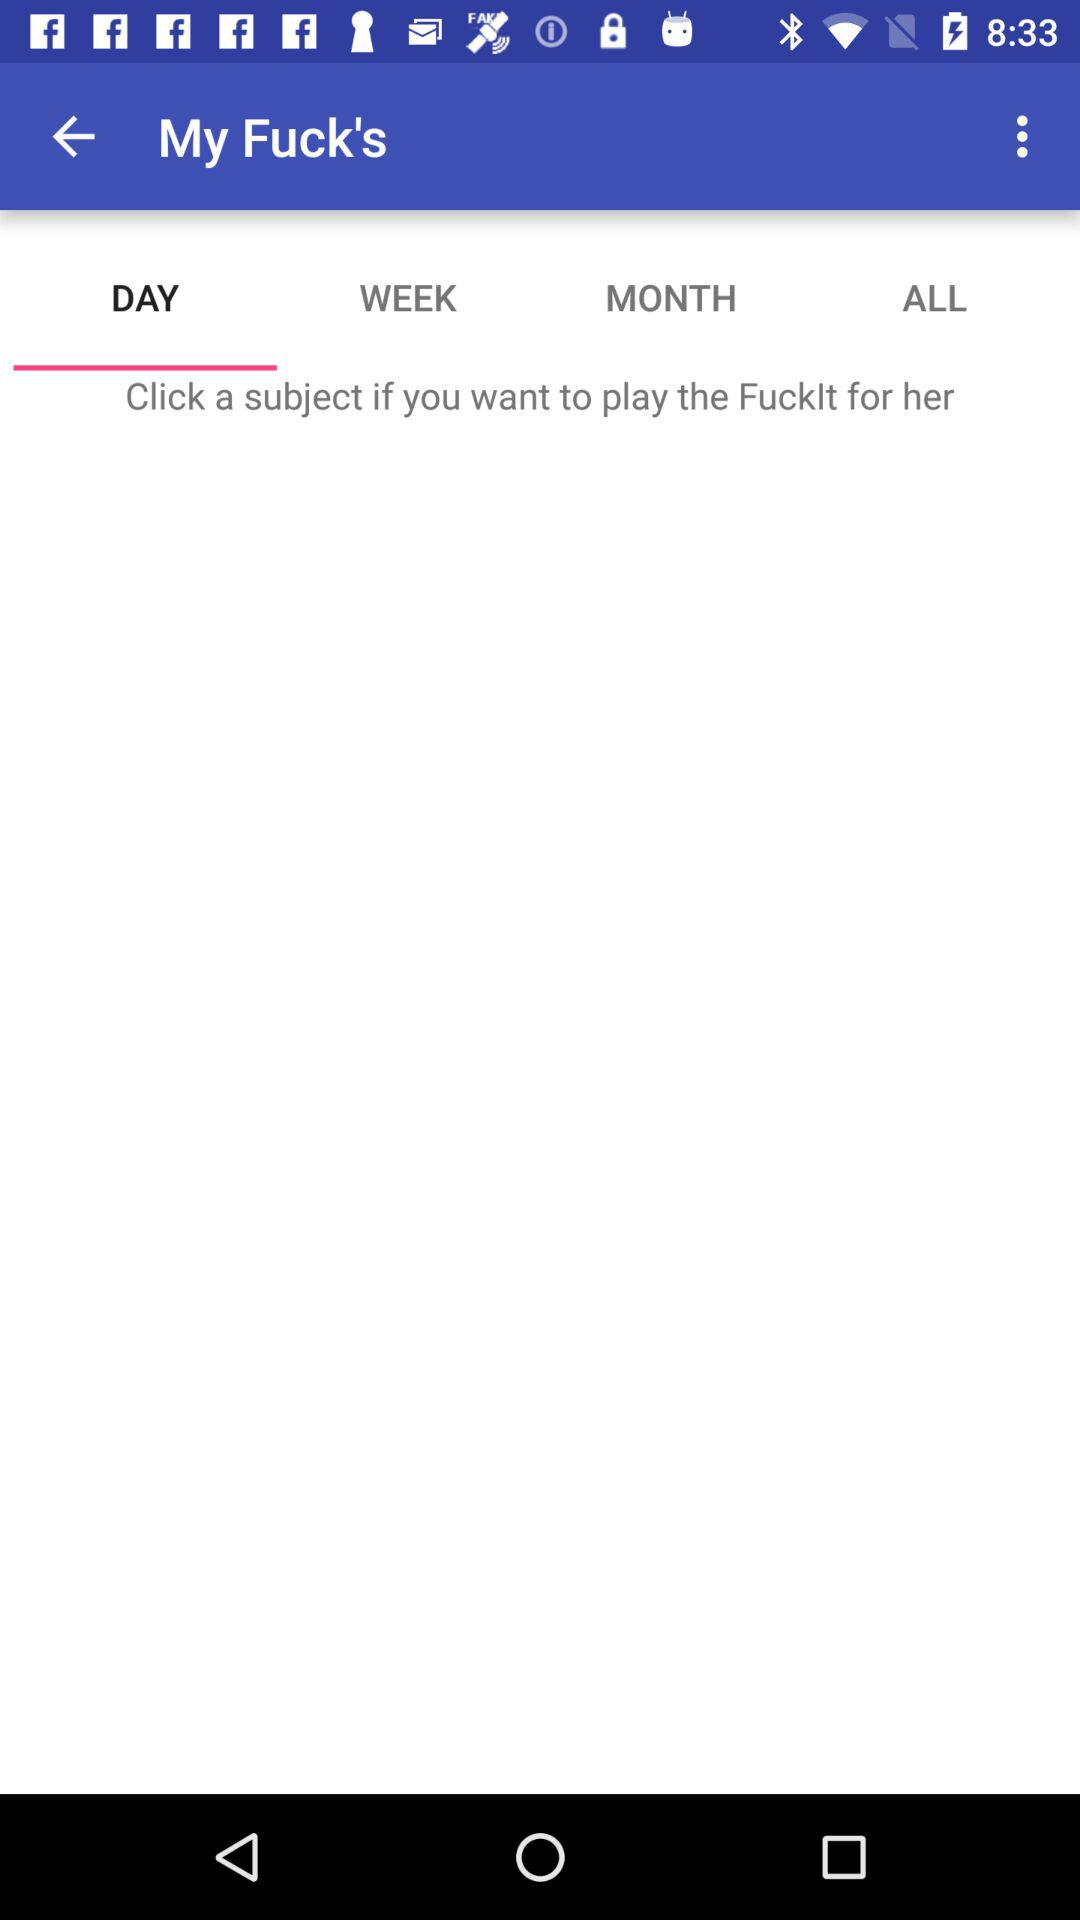What tab is open? The open tab is "DAY". 